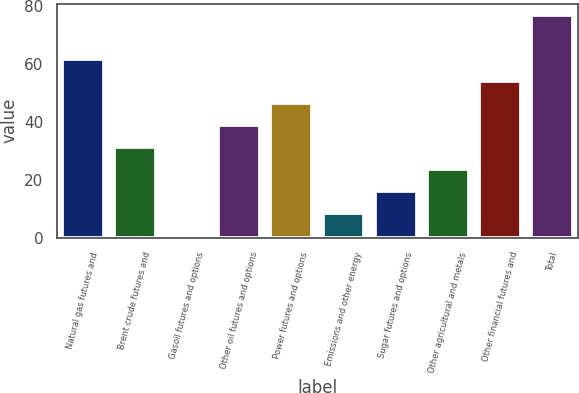Convert chart to OTSL. <chart><loc_0><loc_0><loc_500><loc_500><bar_chart><fcel>Natural gas futures and<fcel>Brent crude futures and<fcel>Gasoil futures and options<fcel>Other oil futures and options<fcel>Power futures and options<fcel>Emissions and other energy<fcel>Sugar futures and options<fcel>Other agricultural and metals<fcel>Other financial futures and<fcel>Total<nl><fcel>61.8<fcel>31.4<fcel>1<fcel>39<fcel>46.6<fcel>8.6<fcel>16.2<fcel>23.8<fcel>54.2<fcel>77<nl></chart> 